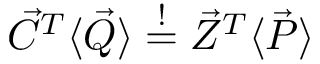Convert formula to latex. <formula><loc_0><loc_0><loc_500><loc_500>\vec { C } ^ { T } \langle \vec { Q } \rangle \stackrel { ! } { = } \vec { Z } ^ { T } \langle \vec { P } \rangle</formula> 